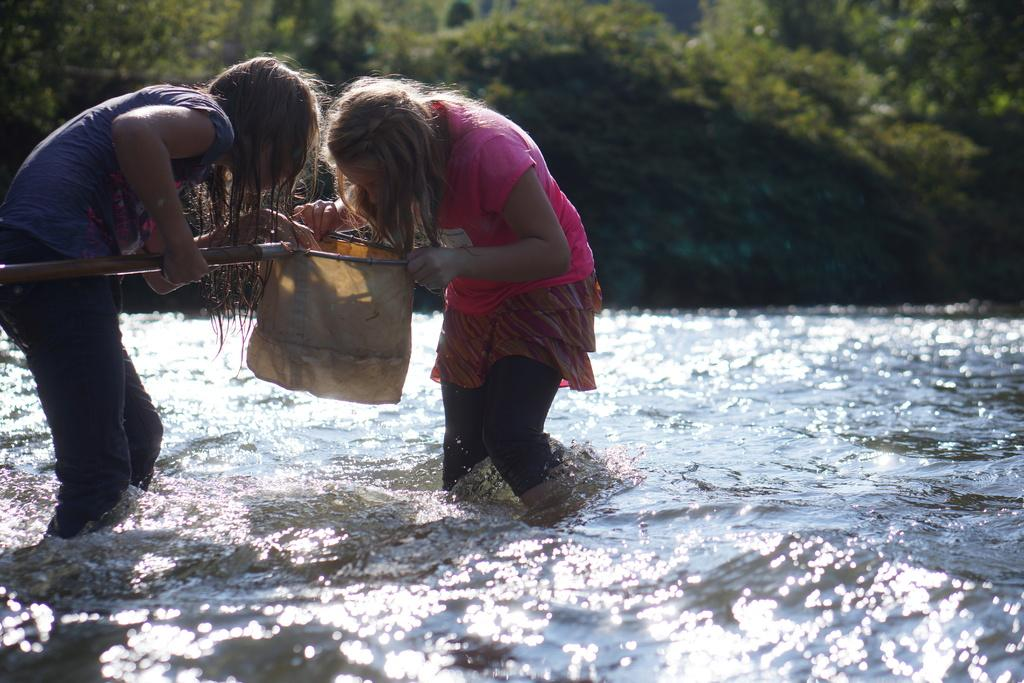How many people are in the water in the image? There are two girls in the water in the image. What can be seen in the background of the image? There are trees visible in the background of the image. What type of jelly is being used to fill the hole in the room in the image? There is no room, hole, or jelly present in the image; it features two girls in the water with trees in the background. 